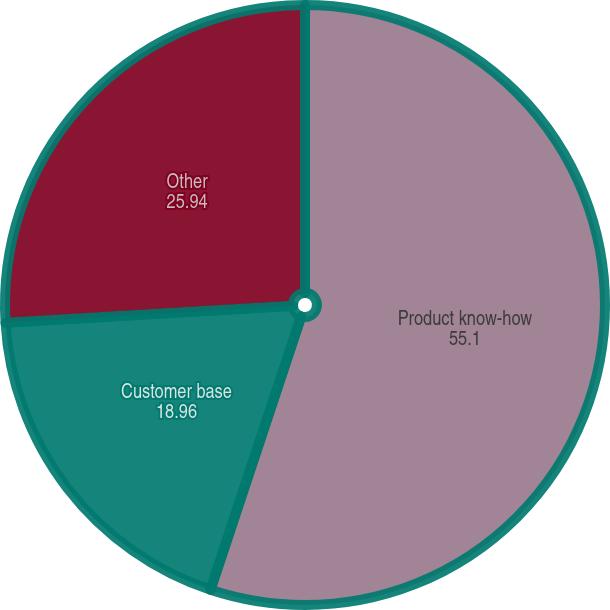Convert chart to OTSL. <chart><loc_0><loc_0><loc_500><loc_500><pie_chart><fcel>Product know-how<fcel>Customer base<fcel>Other<nl><fcel>55.1%<fcel>18.96%<fcel>25.94%<nl></chart> 